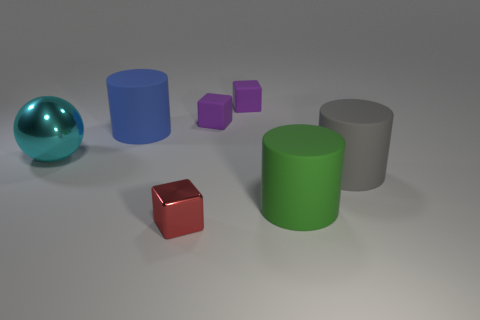Is the number of big gray things that are in front of the large green matte object the same as the number of small brown matte cubes?
Your answer should be compact. Yes. What is the color of the big cylinder that is right of the large rubber cylinder that is in front of the gray thing?
Your answer should be compact. Gray. There is a cylinder that is behind the metallic thing that is to the left of the blue cylinder; what size is it?
Provide a succinct answer. Large. What number of other things are the same size as the green rubber object?
Keep it short and to the point. 3. There is a rubber cylinder that is behind the shiny thing on the left side of the cylinder that is behind the gray cylinder; what is its color?
Your answer should be compact. Blue. How many other objects are there of the same shape as the gray thing?
Offer a very short reply. 2. What shape is the cyan object that is to the left of the large gray rubber object?
Your response must be concise. Sphere. There is a small object that is in front of the gray rubber cylinder; are there any red cubes that are in front of it?
Offer a terse response. No. There is a big matte cylinder that is both behind the big green rubber cylinder and to the right of the tiny red shiny block; what is its color?
Provide a short and direct response. Gray. Are there any big cyan objects on the left side of the shiny object on the left side of the metal thing to the right of the big cyan shiny sphere?
Offer a very short reply. No. 